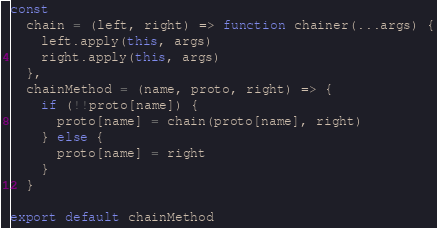Convert code to text. <code><loc_0><loc_0><loc_500><loc_500><_JavaScript_>
const
  chain = (left, right) => function chainer(...args) {
    left.apply(this, args)
    right.apply(this, args)
  },
  chainMethod = (name, proto, right) => {
    if (!!proto[name]) {
      proto[name] = chain(proto[name], right)
    } else {
      proto[name] = right
    }
  }

export default chainMethod
</code> 